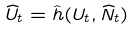<formula> <loc_0><loc_0><loc_500><loc_500>\widehat { U } _ { t } = \hat { h } ( U _ { t } , \widehat { N } _ { t } )</formula> 